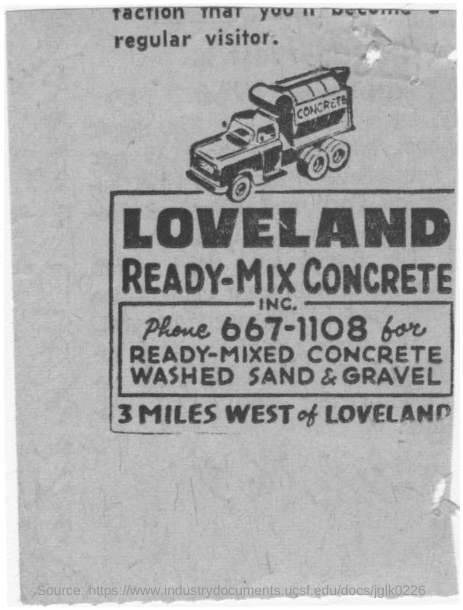Give some essential details in this illustration. The truck's inscription reads, "Concrete. The place mentioned in bold is Loveland The phone number for ready-mix concrete, washed sand & gravel is 667-1108. 